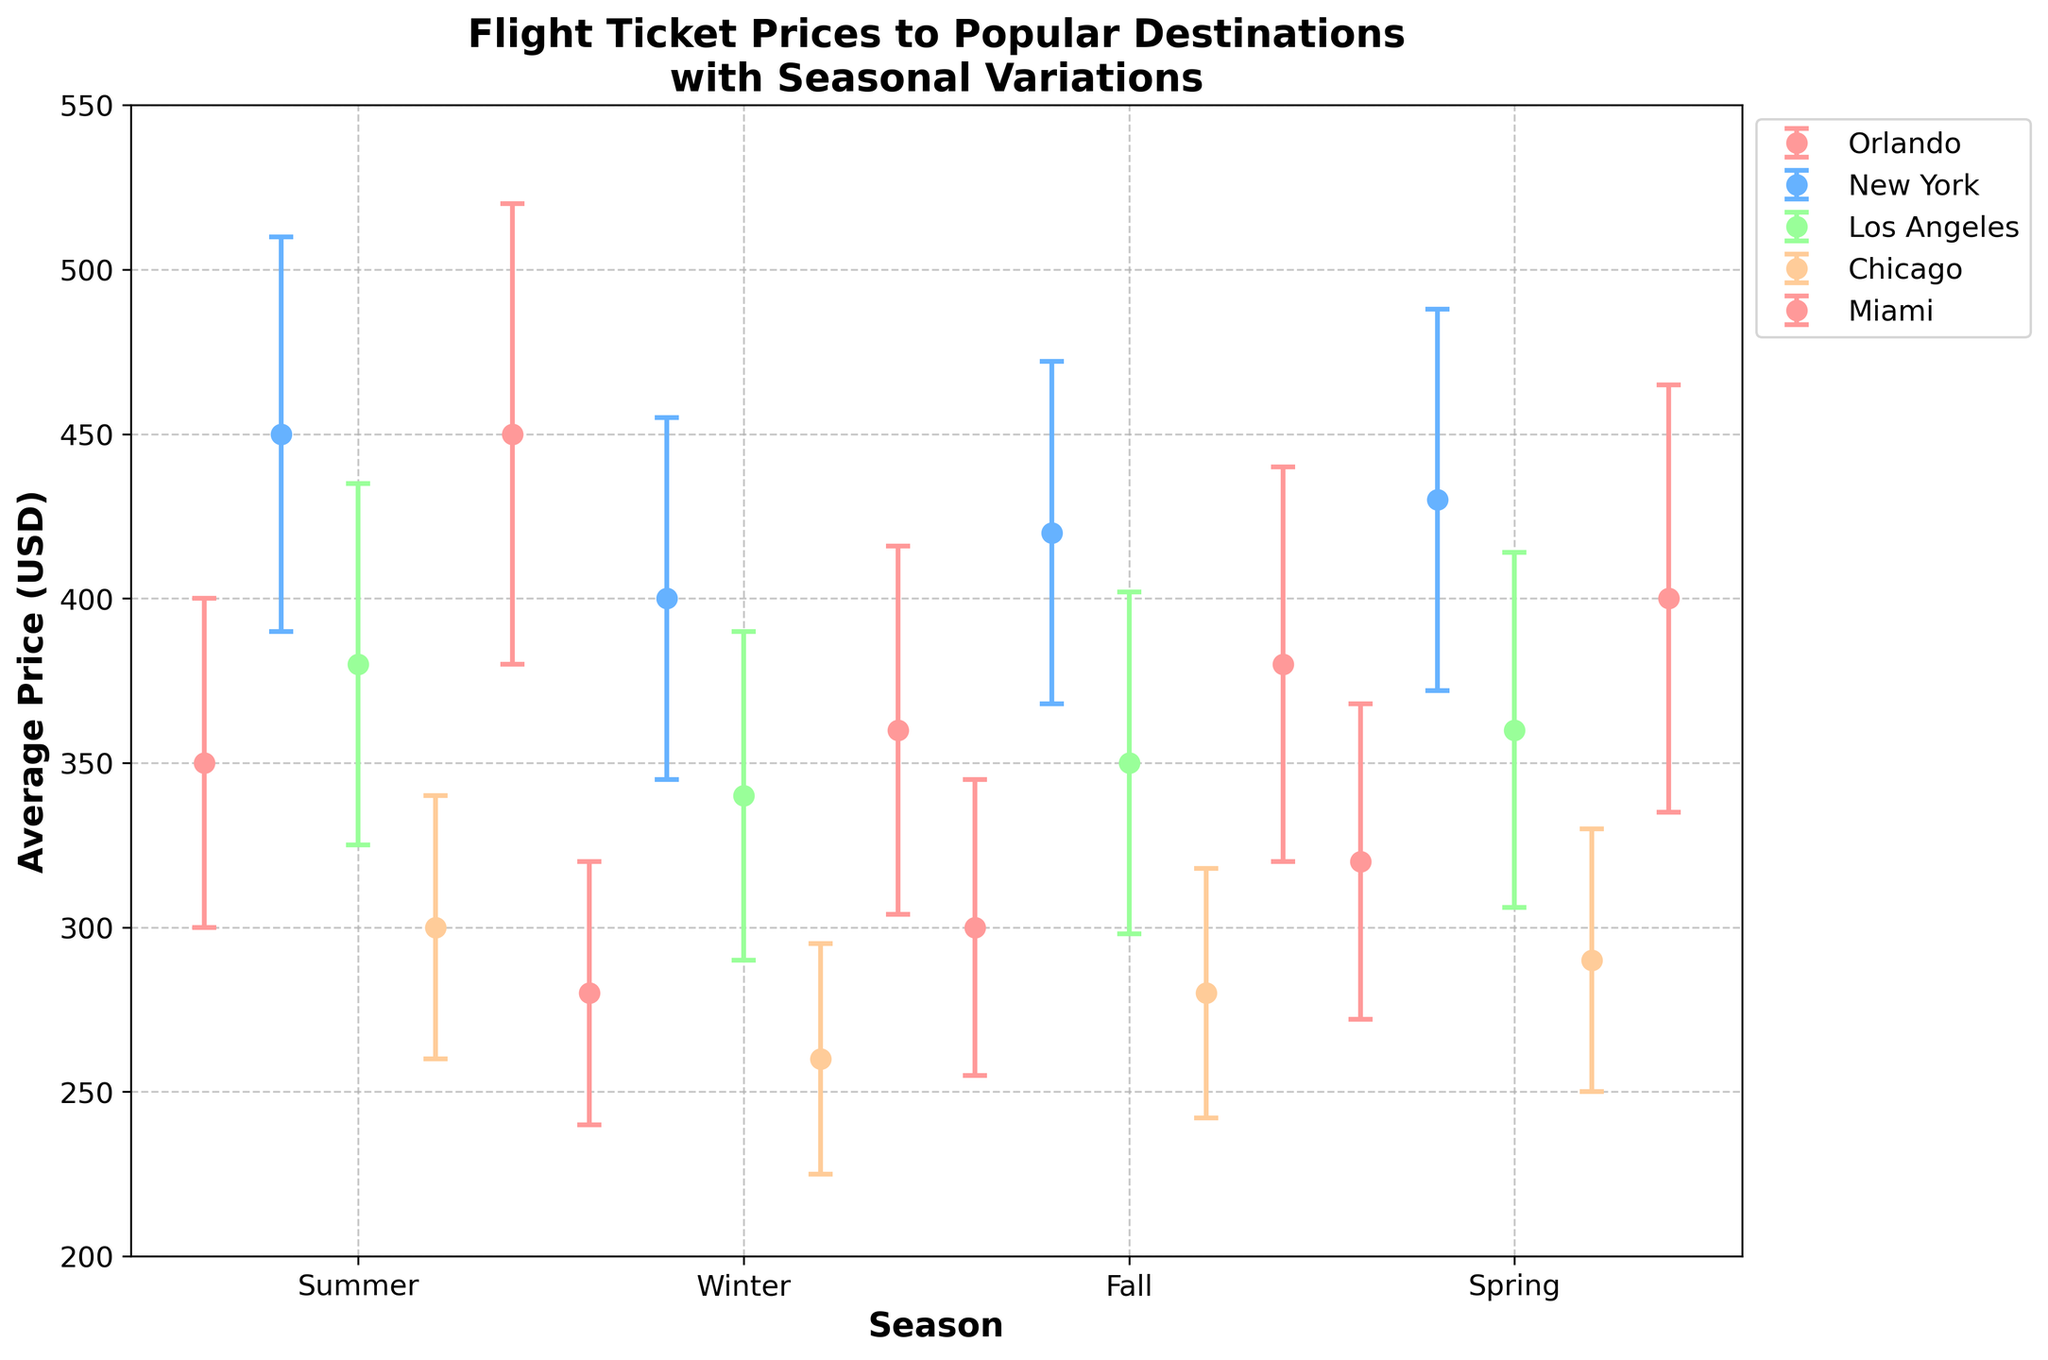What is the title of the figure? The title is located at the top of the figure and usually summarizes what the figure is about. In this case, it states that the figure shows flight ticket prices to popular destinations with seasonal variations.
Answer: Flight Ticket Prices to Popular Destinations with Seasonal Variations Which destination has the highest average price during the Summer? By looking at the scatter points for each destination in the Summer, the highest price value can be identified. For the highest point, we see it belongs to Miami.
Answer: Miami What is the range of average prices for flights to New York across all seasons? The range is calculated by finding the difference between the maximum and minimum values of average prices for New York. The maximum average price is 450 USD (Summer) and the minimum is 400 USD (Winter). The range is 450 - 400 = 50 USD.
Answer: 50 USD Which destination has the greatest variation in ticket prices during Winter? The variation is represented by the error bar (standard deviation). Identify the destination with the longest error bar (highest standard deviation) during Winter. Miami has the highest standard deviation (56 USD).
Answer: Miami How does the average flight price to Los Angeles in Fall compare to that in Spring? Determine the average prices for Los Angeles in Fall and Spring from the figure, then compare them. Fall: 350 USD, Spring: 360 USD, Fall is 10 USD cheaper than Spring.
Answer: Fall is 10 USD cheaper than Spring Which season has the lowest average flight price for Chicago? By identifying the lowest point among the seasonal data points for Chicago, we see that the Winter season has the lowest average price of 260 USD.
Answer: Winter What is the average flight price to Orlando in Summer plus the price standard deviation? Add the average price in Summer (350 USD) to the standard deviation (50 USD). 350 + 50 = 400 USD.
Answer: 400 USD Which destination has the most stable (least variable) price across all seasons? Stability can be assessed by the consistency of average prices and shorter error bars. By observing all destinations, Chicago shows the least variation both in terms of average prices and standard deviations.
Answer: Chicago Are the flight prices for Miami consistently higher across all seasons compared to Chicago? Compare the average prices for Miami and Chicago for each season. Miami's prices are higher in every season compared to those of Chicago.
Answer: Yes During which season does New York have its second highest average price? Rank the seasonal average prices for New York and identify the second highest one. The prices are: 450 (Summer), 430 (Spring), 420 (Fall), 400 (Winter). Spring has the second highest average price of 430 USD.
Answer: Spring 